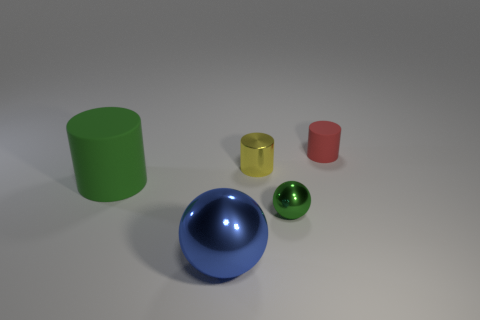Is the number of small green metal spheres greater than the number of large green metallic objects?
Your answer should be compact. Yes. Are there any large rubber cylinders?
Make the answer very short. Yes. How many things are tiny objects behind the yellow cylinder or things that are left of the yellow object?
Provide a short and direct response. 3. Is the big cylinder the same color as the tiny metal sphere?
Your answer should be very brief. Yes. Are there fewer tiny green objects than metal spheres?
Ensure brevity in your answer.  Yes. There is a tiny green object; are there any small cylinders behind it?
Offer a terse response. Yes. Is the tiny ball made of the same material as the small yellow cylinder?
Offer a very short reply. Yes. The metallic thing that is the same shape as the big matte object is what color?
Your answer should be very brief. Yellow. Is the color of the tiny object that is in front of the big rubber cylinder the same as the big rubber cylinder?
Offer a very short reply. Yes. What shape is the thing that is the same color as the small ball?
Provide a succinct answer. Cylinder. 